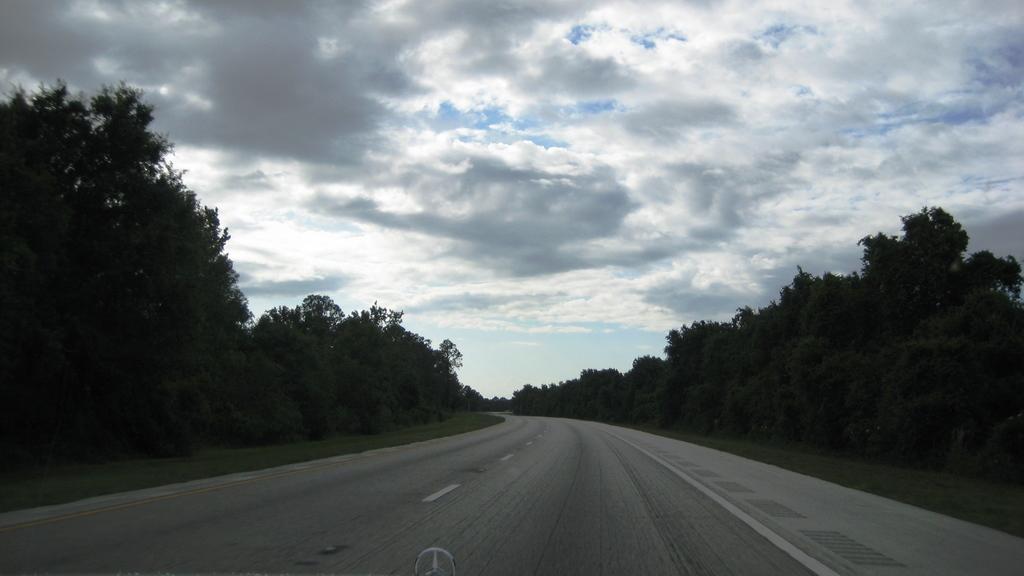Describe this image in one or two sentences. In this image, we can see a road, at the right and left sides, there are some green color trees, at the top there is a sky which is cloudy. 